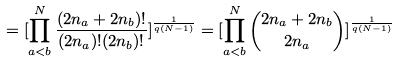<formula> <loc_0><loc_0><loc_500><loc_500>= [ \prod _ { a < b } ^ { N } \frac { ( 2 n _ { a } + 2 n _ { b } ) ! } { ( 2 n _ { a } ) ! ( 2 n _ { b } ) ! } ] ^ { \frac { 1 } { q ( N - 1 ) } } = [ \prod _ { a < b } ^ { N } \binom { 2 n _ { a } + 2 n _ { b } } { 2 n _ { a } } ] ^ { \frac { 1 } { q ( N - 1 ) } }</formula> 